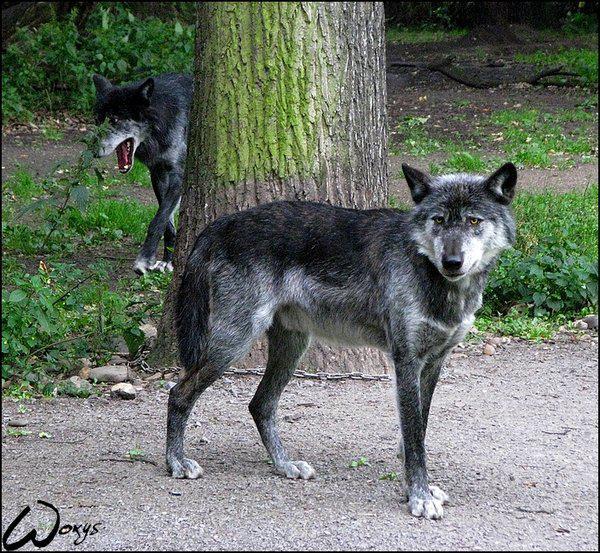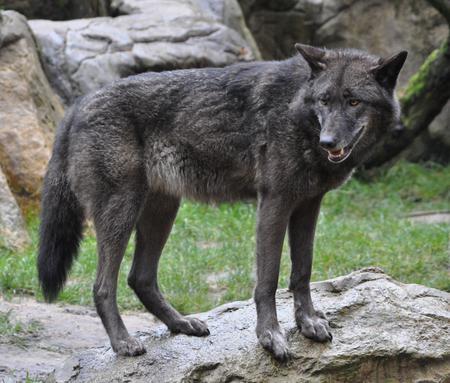The first image is the image on the left, the second image is the image on the right. Given the left and right images, does the statement "There is exactly one animal in the image on the right." hold true? Answer yes or no. Yes. 